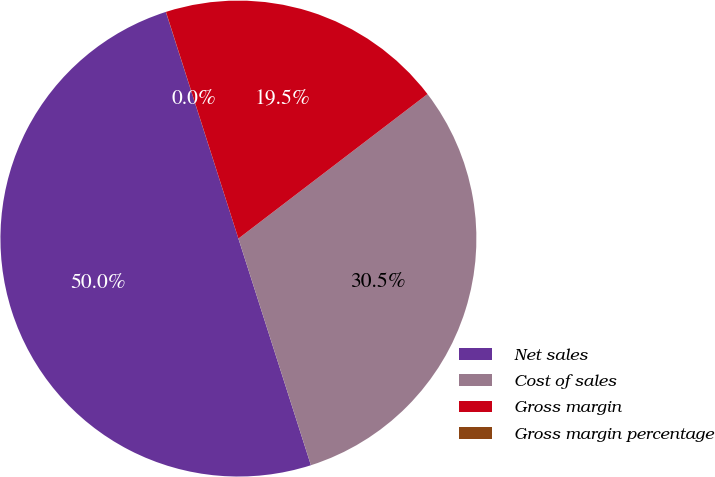Convert chart to OTSL. <chart><loc_0><loc_0><loc_500><loc_500><pie_chart><fcel>Net sales<fcel>Cost of sales<fcel>Gross margin<fcel>Gross margin percentage<nl><fcel>50.0%<fcel>30.46%<fcel>19.54%<fcel>0.01%<nl></chart> 